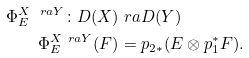<formula> <loc_0><loc_0><loc_500><loc_500>\Phi _ { E } ^ { X \ r a Y } \colon D ( X ) & \ r a D ( Y ) \\ \Phi _ { E } ^ { X \ r a Y } ( F ) & = p _ { 2 * } ( E \otimes p _ { 1 } ^ { * } F ) .</formula> 